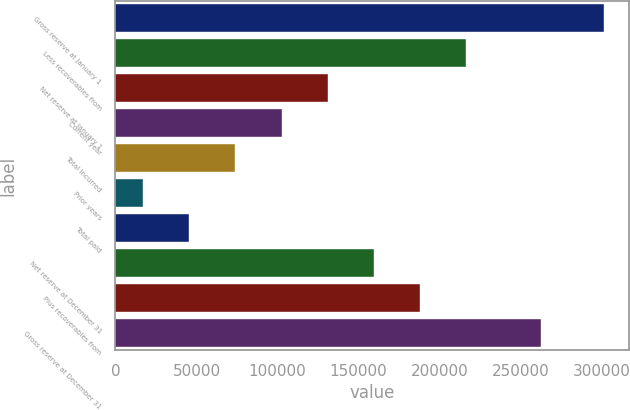Convert chart. <chart><loc_0><loc_0><loc_500><loc_500><bar_chart><fcel>Gross reserve at January 1<fcel>Less recoverables from<fcel>Net reserve at January 1<fcel>Current year<fcel>Total incurred<fcel>Prior years<fcel>Total paid<fcel>Net reserve at December 31<fcel>Plus recoverables from<fcel>Gross reserve at December 31<nl><fcel>301518<fcel>216217<fcel>130916<fcel>102483<fcel>74049.2<fcel>17182<fcel>45615.6<fcel>159350<fcel>187784<fcel>262763<nl></chart> 